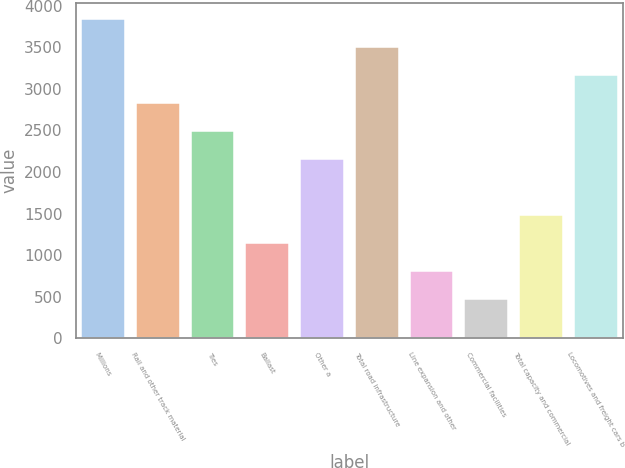Convert chart to OTSL. <chart><loc_0><loc_0><loc_500><loc_500><bar_chart><fcel>Millions<fcel>Rail and other track material<fcel>Ties<fcel>Ballast<fcel>Other a<fcel>Total road infrastructure<fcel>Line expansion and other<fcel>Commercial facilities<fcel>Total capacity and commercial<fcel>Locomotives and freight cars b<nl><fcel>3841.7<fcel>2831.6<fcel>2494.9<fcel>1148.1<fcel>2158.2<fcel>3505<fcel>811.4<fcel>474.7<fcel>1484.8<fcel>3168.3<nl></chart> 